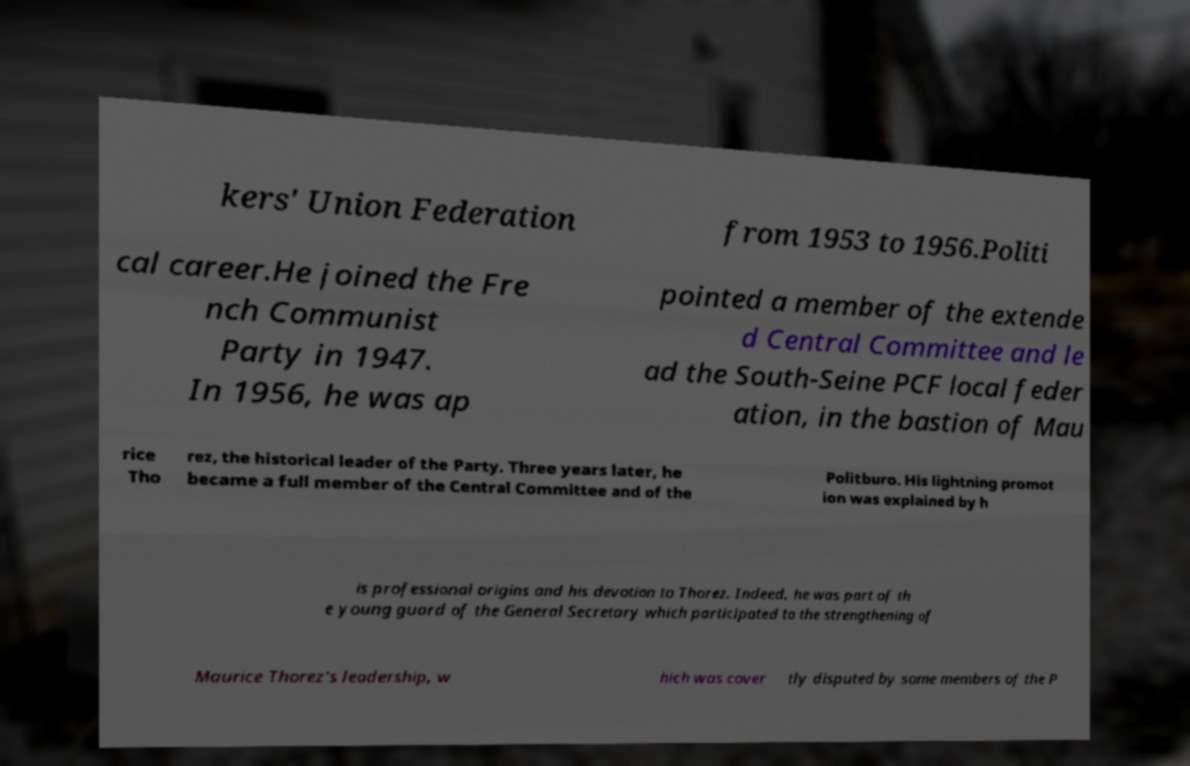What messages or text are displayed in this image? I need them in a readable, typed format. kers' Union Federation from 1953 to 1956.Politi cal career.He joined the Fre nch Communist Party in 1947. In 1956, he was ap pointed a member of the extende d Central Committee and le ad the South-Seine PCF local feder ation, in the bastion of Mau rice Tho rez, the historical leader of the Party. Three years later, he became a full member of the Central Committee and of the Politburo. His lightning promot ion was explained by h is professional origins and his devotion to Thorez. Indeed, he was part of th e young guard of the General Secretary which participated to the strengthening of Maurice Thorez's leadership, w hich was cover tly disputed by some members of the P 